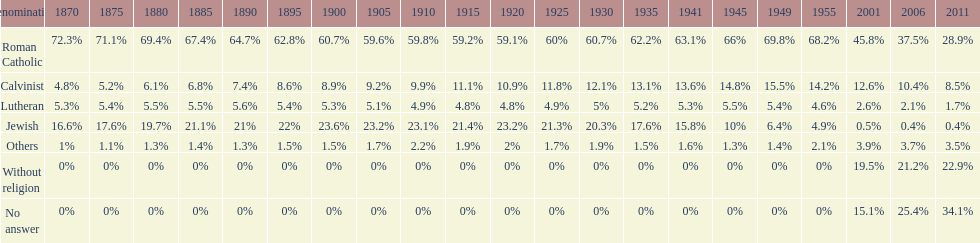What is the number of denominations that maintained a minimum of 20%? 1. 